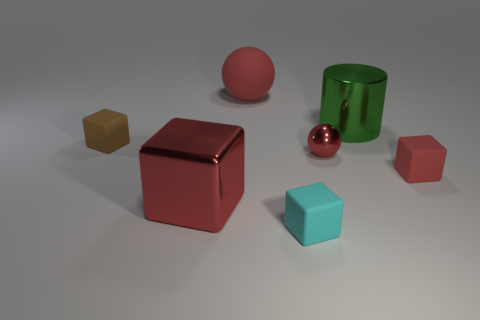There is a rubber object behind the big green thing; what color is it?
Offer a very short reply. Red. Does the red matte cube have the same size as the brown rubber object?
Keep it short and to the point. Yes. There is a big red object that is in front of the red object behind the small shiny sphere; what is its material?
Offer a terse response. Metal. What number of big metallic things are the same color as the tiny metallic sphere?
Your answer should be compact. 1. Are there fewer big metallic blocks in front of the red shiny sphere than green cylinders?
Provide a short and direct response. No. What color is the matte cube that is on the right side of the sphere in front of the small brown rubber cube?
Offer a very short reply. Red. There is a matte object that is on the left side of the red thing that is in front of the red rubber object on the right side of the big red sphere; what is its size?
Your answer should be compact. Small. Are there fewer small red balls that are left of the tiny brown matte cube than tiny shiny spheres on the right side of the big shiny block?
Ensure brevity in your answer.  Yes. What number of balls have the same material as the big green cylinder?
Give a very brief answer. 1. Are there any big green metallic cylinders that are to the right of the cyan block on the left side of the metallic thing that is behind the small red shiny thing?
Provide a short and direct response. Yes. 